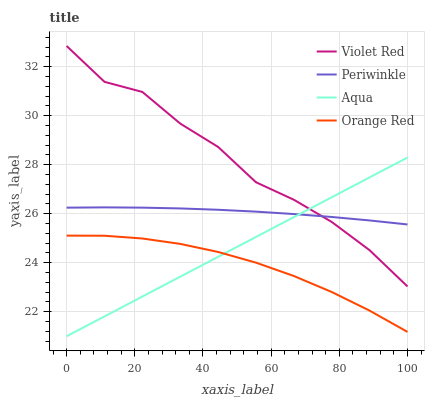Does Orange Red have the minimum area under the curve?
Answer yes or no. Yes. Does Violet Red have the maximum area under the curve?
Answer yes or no. Yes. Does Periwinkle have the minimum area under the curve?
Answer yes or no. No. Does Periwinkle have the maximum area under the curve?
Answer yes or no. No. Is Aqua the smoothest?
Answer yes or no. Yes. Is Violet Red the roughest?
Answer yes or no. Yes. Is Periwinkle the smoothest?
Answer yes or no. No. Is Periwinkle the roughest?
Answer yes or no. No. Does Aqua have the lowest value?
Answer yes or no. Yes. Does Violet Red have the lowest value?
Answer yes or no. No. Does Violet Red have the highest value?
Answer yes or no. Yes. Does Periwinkle have the highest value?
Answer yes or no. No. Is Orange Red less than Periwinkle?
Answer yes or no. Yes. Is Periwinkle greater than Orange Red?
Answer yes or no. Yes. Does Aqua intersect Periwinkle?
Answer yes or no. Yes. Is Aqua less than Periwinkle?
Answer yes or no. No. Is Aqua greater than Periwinkle?
Answer yes or no. No. Does Orange Red intersect Periwinkle?
Answer yes or no. No. 